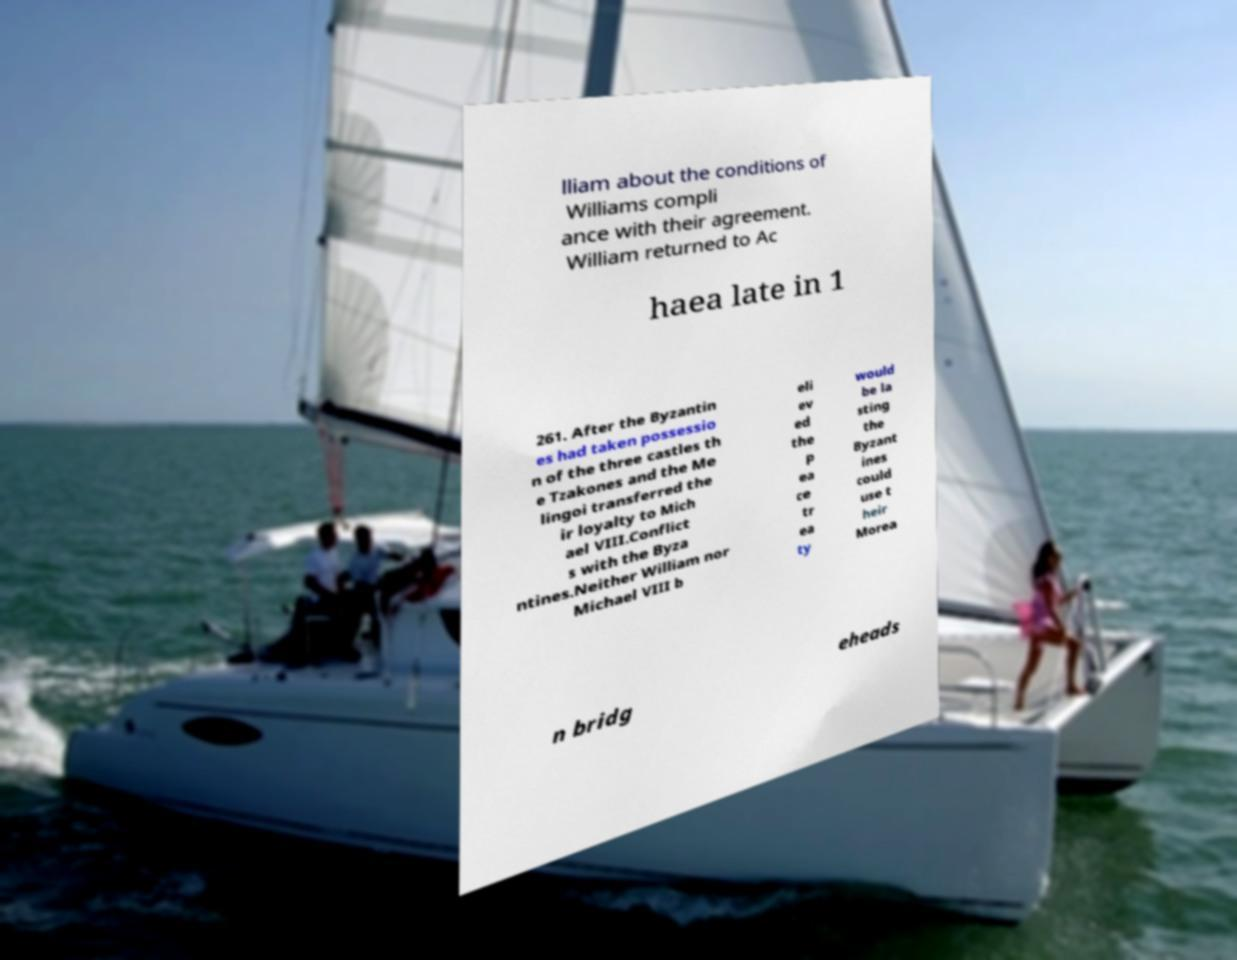Please identify and transcribe the text found in this image. lliam about the conditions of Williams compli ance with their agreement. William returned to Ac haea late in 1 261. After the Byzantin es had taken possessio n of the three castles th e Tzakones and the Me lingoi transferred the ir loyalty to Mich ael VIII.Conflict s with the Byza ntines.Neither William nor Michael VIII b eli ev ed the p ea ce tr ea ty would be la sting the Byzant ines could use t heir Morea n bridg eheads 